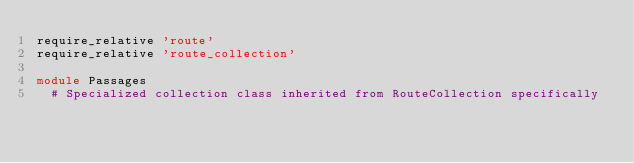<code> <loc_0><loc_0><loc_500><loc_500><_Ruby_>require_relative 'route'
require_relative 'route_collection'

module Passages
  # Specialized collection class inherited from RouteCollection specifically</code> 